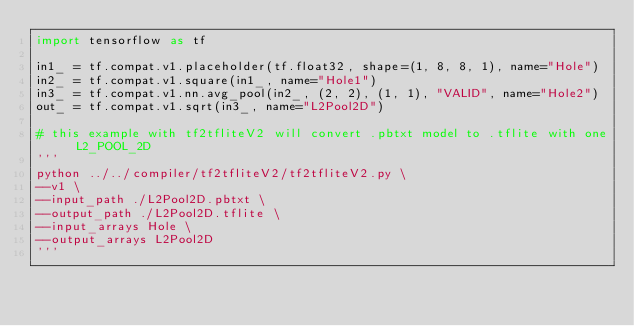<code> <loc_0><loc_0><loc_500><loc_500><_Python_>import tensorflow as tf

in1_ = tf.compat.v1.placeholder(tf.float32, shape=(1, 8, 8, 1), name="Hole")
in2_ = tf.compat.v1.square(in1_, name="Hole1")
in3_ = tf.compat.v1.nn.avg_pool(in2_, (2, 2), (1, 1), "VALID", name="Hole2")
out_ = tf.compat.v1.sqrt(in3_, name="L2Pool2D")

# this example with tf2tfliteV2 will convert .pbtxt model to .tflite with one L2_POOL_2D
'''
python ../../compiler/tf2tfliteV2/tf2tfliteV2.py \
--v1 \
--input_path ./L2Pool2D.pbtxt \
--output_path ./L2Pool2D.tflite \
--input_arrays Hole \
--output_arrays L2Pool2D
'''
</code> 